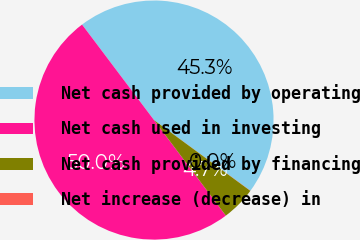Convert chart. <chart><loc_0><loc_0><loc_500><loc_500><pie_chart><fcel>Net cash provided by operating<fcel>Net cash used in investing<fcel>Net cash provided by financing<fcel>Net increase (decrease) in<nl><fcel>45.34%<fcel>49.98%<fcel>4.66%<fcel>0.02%<nl></chart> 